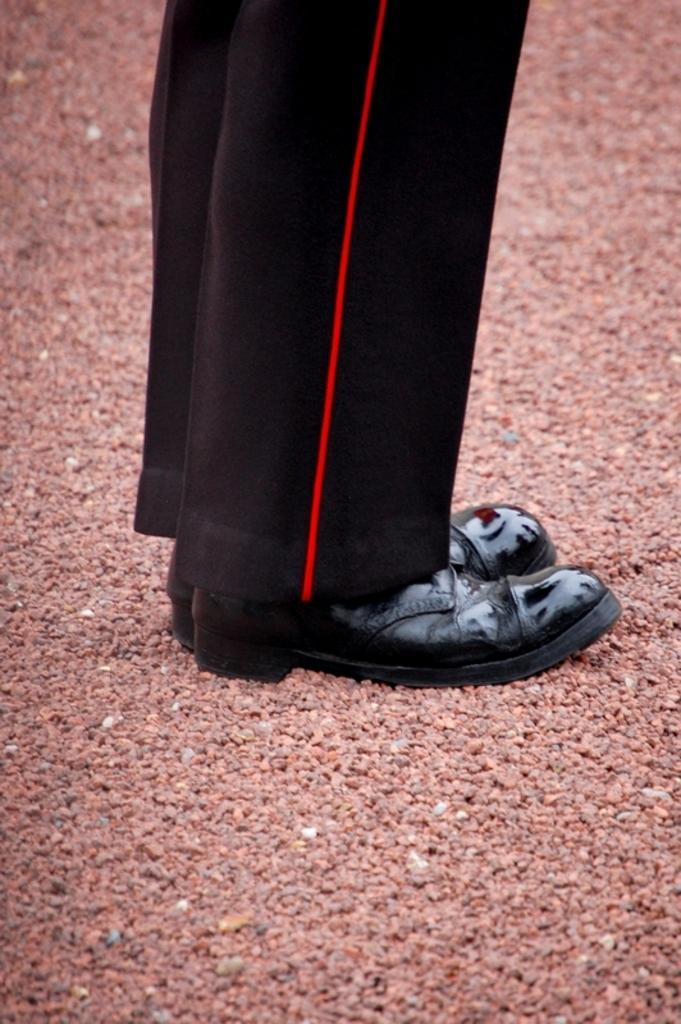Please provide a concise description of this image. As we can see in the image there is a person wearing black color dress and black color shoes. There are pebbles over here. 